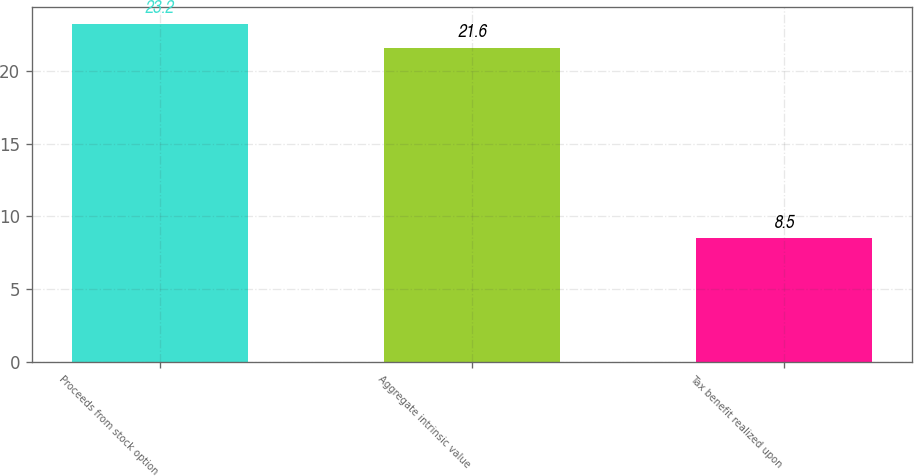<chart> <loc_0><loc_0><loc_500><loc_500><bar_chart><fcel>Proceeds from stock option<fcel>Aggregate intrinsic value<fcel>Tax benefit realized upon<nl><fcel>23.2<fcel>21.6<fcel>8.5<nl></chart> 